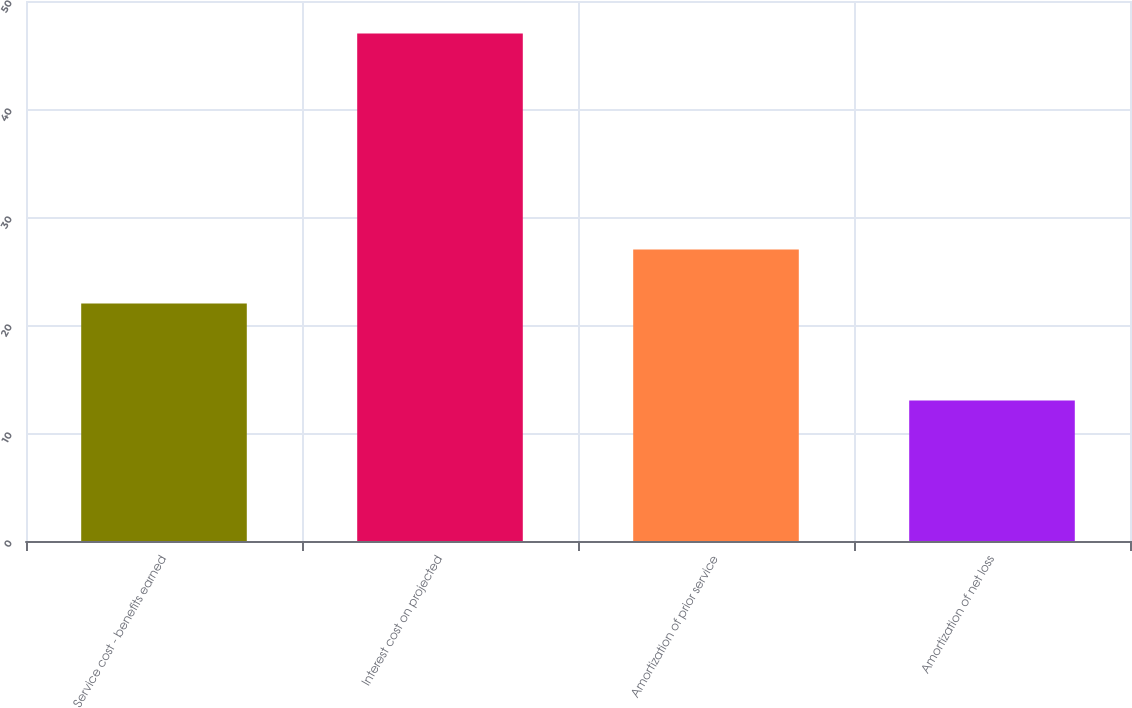Convert chart. <chart><loc_0><loc_0><loc_500><loc_500><bar_chart><fcel>Service cost - benefits earned<fcel>Interest cost on projected<fcel>Amortization of prior service<fcel>Amortization of net loss<nl><fcel>22<fcel>47<fcel>27<fcel>13<nl></chart> 